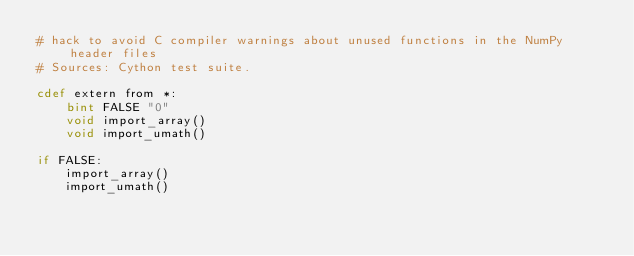<code> <loc_0><loc_0><loc_500><loc_500><_Cython_># hack to avoid C compiler warnings about unused functions in the NumPy header files
# Sources: Cython test suite.

cdef extern from *:
    bint FALSE "0"
    void import_array()
    void import_umath()

if FALSE:
    import_array()
    import_umath()
</code> 